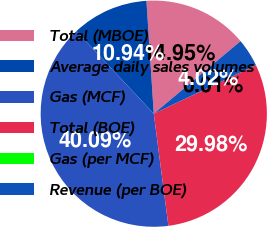Convert chart. <chart><loc_0><loc_0><loc_500><loc_500><pie_chart><fcel>Total (MBOE)<fcel>Average daily sales volumes<fcel>Gas (MCF)<fcel>Total (BOE)<fcel>Gas (per MCF)<fcel>Revenue (per BOE)<nl><fcel>14.95%<fcel>10.94%<fcel>40.09%<fcel>29.98%<fcel>0.01%<fcel>4.02%<nl></chart> 